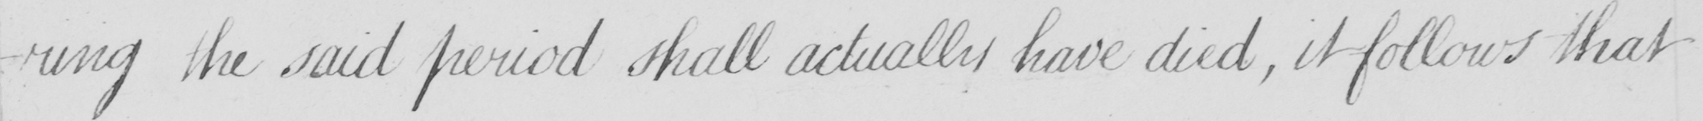What text is written in this handwritten line? -ring the said period shall actually have died , it follows that 